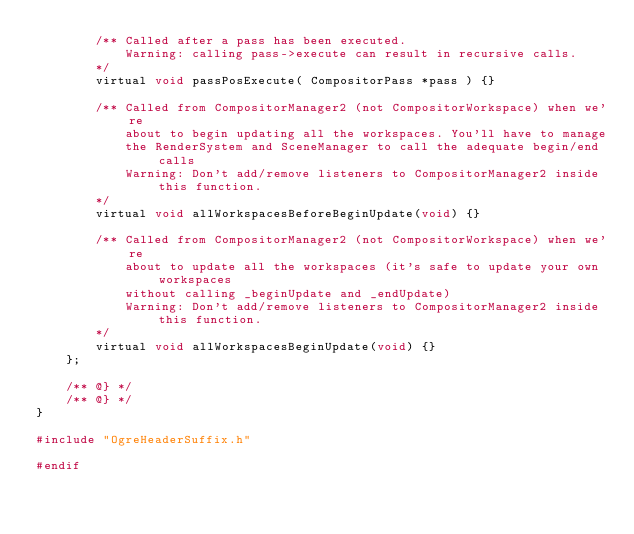Convert code to text. <code><loc_0><loc_0><loc_500><loc_500><_C_>        /** Called after a pass has been executed.
            Warning: calling pass->execute can result in recursive calls.
        */
        virtual void passPosExecute( CompositorPass *pass ) {}

        /** Called from CompositorManager2 (not CompositorWorkspace) when we're
            about to begin updating all the workspaces. You'll have to manage
            the RenderSystem and SceneManager to call the adequate begin/end calls
            Warning: Don't add/remove listeners to CompositorManager2 inside this function.
        */
        virtual void allWorkspacesBeforeBeginUpdate(void) {}

        /** Called from CompositorManager2 (not CompositorWorkspace) when we're
            about to update all the workspaces (it's safe to update your own workspaces
            without calling _beginUpdate and _endUpdate)
            Warning: Don't add/remove listeners to CompositorManager2 inside this function.
        */
        virtual void allWorkspacesBeginUpdate(void) {}
    };

    /** @} */
    /** @} */
}

#include "OgreHeaderSuffix.h"

#endif
</code> 